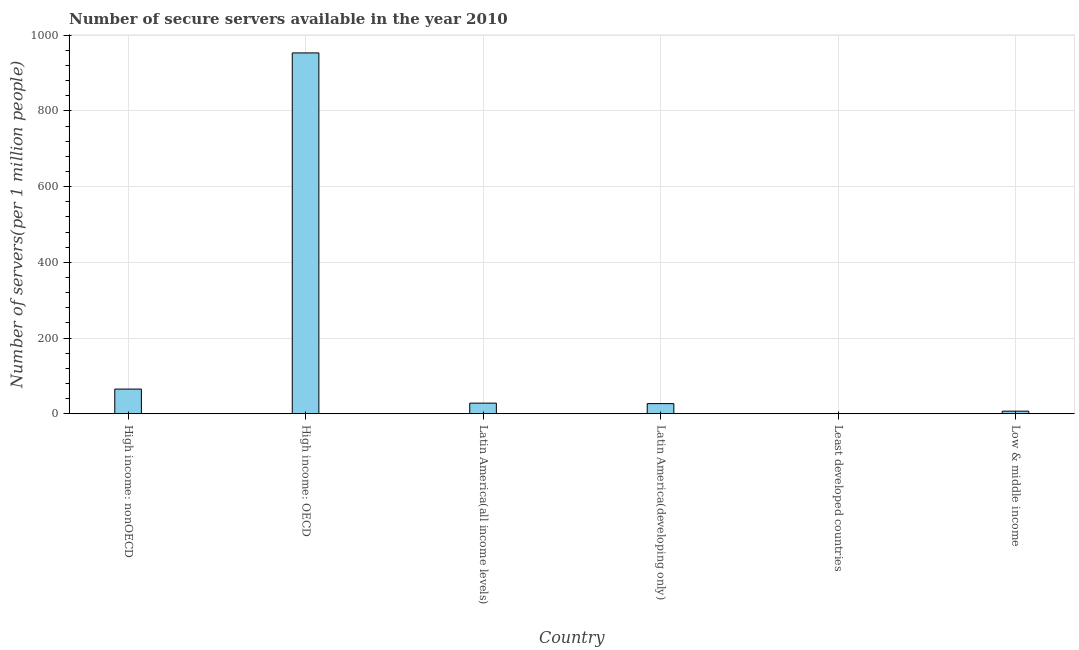Does the graph contain any zero values?
Give a very brief answer. No. What is the title of the graph?
Make the answer very short. Number of secure servers available in the year 2010. What is the label or title of the X-axis?
Ensure brevity in your answer.  Country. What is the label or title of the Y-axis?
Ensure brevity in your answer.  Number of servers(per 1 million people). What is the number of secure internet servers in High income: nonOECD?
Offer a terse response. 65.12. Across all countries, what is the maximum number of secure internet servers?
Provide a short and direct response. 953.1. Across all countries, what is the minimum number of secure internet servers?
Keep it short and to the point. 0.58. In which country was the number of secure internet servers maximum?
Provide a short and direct response. High income: OECD. In which country was the number of secure internet servers minimum?
Your answer should be compact. Least developed countries. What is the sum of the number of secure internet servers?
Offer a very short reply. 1080.34. What is the difference between the number of secure internet servers in Latin America(developing only) and Low & middle income?
Ensure brevity in your answer.  19.97. What is the average number of secure internet servers per country?
Keep it short and to the point. 180.06. What is the median number of secure internet servers?
Your answer should be very brief. 27.37. In how many countries, is the number of secure internet servers greater than 200 ?
Your answer should be very brief. 1. What is the ratio of the number of secure internet servers in High income: nonOECD to that in Low & middle income?
Give a very brief answer. 9.6. Is the number of secure internet servers in High income: nonOECD less than that in Low & middle income?
Ensure brevity in your answer.  No. Is the difference between the number of secure internet servers in Latin America(developing only) and Least developed countries greater than the difference between any two countries?
Keep it short and to the point. No. What is the difference between the highest and the second highest number of secure internet servers?
Make the answer very short. 887.98. Is the sum of the number of secure internet servers in High income: OECD and Latin America(developing only) greater than the maximum number of secure internet servers across all countries?
Your answer should be compact. Yes. What is the difference between the highest and the lowest number of secure internet servers?
Your answer should be very brief. 952.52. In how many countries, is the number of secure internet servers greater than the average number of secure internet servers taken over all countries?
Keep it short and to the point. 1. How many bars are there?
Your answer should be compact. 6. Are all the bars in the graph horizontal?
Your answer should be very brief. No. How many countries are there in the graph?
Your answer should be very brief. 6. What is the difference between two consecutive major ticks on the Y-axis?
Ensure brevity in your answer.  200. What is the Number of servers(per 1 million people) of High income: nonOECD?
Offer a terse response. 65.12. What is the Number of servers(per 1 million people) of High income: OECD?
Ensure brevity in your answer.  953.1. What is the Number of servers(per 1 million people) in Latin America(all income levels)?
Your response must be concise. 27.99. What is the Number of servers(per 1 million people) of Latin America(developing only)?
Provide a short and direct response. 26.75. What is the Number of servers(per 1 million people) in Least developed countries?
Make the answer very short. 0.58. What is the Number of servers(per 1 million people) of Low & middle income?
Make the answer very short. 6.78. What is the difference between the Number of servers(per 1 million people) in High income: nonOECD and High income: OECD?
Your answer should be compact. -887.98. What is the difference between the Number of servers(per 1 million people) in High income: nonOECD and Latin America(all income levels)?
Offer a very short reply. 37.13. What is the difference between the Number of servers(per 1 million people) in High income: nonOECD and Latin America(developing only)?
Keep it short and to the point. 38.37. What is the difference between the Number of servers(per 1 million people) in High income: nonOECD and Least developed countries?
Keep it short and to the point. 64.54. What is the difference between the Number of servers(per 1 million people) in High income: nonOECD and Low & middle income?
Your answer should be compact. 58.34. What is the difference between the Number of servers(per 1 million people) in High income: OECD and Latin America(all income levels)?
Give a very brief answer. 925.11. What is the difference between the Number of servers(per 1 million people) in High income: OECD and Latin America(developing only)?
Provide a succinct answer. 926.35. What is the difference between the Number of servers(per 1 million people) in High income: OECD and Least developed countries?
Your response must be concise. 952.52. What is the difference between the Number of servers(per 1 million people) in High income: OECD and Low & middle income?
Ensure brevity in your answer.  946.32. What is the difference between the Number of servers(per 1 million people) in Latin America(all income levels) and Latin America(developing only)?
Keep it short and to the point. 1.24. What is the difference between the Number of servers(per 1 million people) in Latin America(all income levels) and Least developed countries?
Your response must be concise. 27.41. What is the difference between the Number of servers(per 1 million people) in Latin America(all income levels) and Low & middle income?
Your response must be concise. 21.21. What is the difference between the Number of servers(per 1 million people) in Latin America(developing only) and Least developed countries?
Provide a short and direct response. 26.17. What is the difference between the Number of servers(per 1 million people) in Latin America(developing only) and Low & middle income?
Ensure brevity in your answer.  19.97. What is the ratio of the Number of servers(per 1 million people) in High income: nonOECD to that in High income: OECD?
Offer a very short reply. 0.07. What is the ratio of the Number of servers(per 1 million people) in High income: nonOECD to that in Latin America(all income levels)?
Your answer should be very brief. 2.33. What is the ratio of the Number of servers(per 1 million people) in High income: nonOECD to that in Latin America(developing only)?
Keep it short and to the point. 2.43. What is the ratio of the Number of servers(per 1 million people) in High income: nonOECD to that in Least developed countries?
Your response must be concise. 111.71. What is the ratio of the Number of servers(per 1 million people) in High income: nonOECD to that in Low & middle income?
Give a very brief answer. 9.6. What is the ratio of the Number of servers(per 1 million people) in High income: OECD to that in Latin America(all income levels)?
Give a very brief answer. 34.05. What is the ratio of the Number of servers(per 1 million people) in High income: OECD to that in Latin America(developing only)?
Ensure brevity in your answer.  35.62. What is the ratio of the Number of servers(per 1 million people) in High income: OECD to that in Least developed countries?
Ensure brevity in your answer.  1634.97. What is the ratio of the Number of servers(per 1 million people) in High income: OECD to that in Low & middle income?
Your answer should be compact. 140.51. What is the ratio of the Number of servers(per 1 million people) in Latin America(all income levels) to that in Latin America(developing only)?
Your response must be concise. 1.05. What is the ratio of the Number of servers(per 1 million people) in Latin America(all income levels) to that in Least developed countries?
Give a very brief answer. 48.02. What is the ratio of the Number of servers(per 1 million people) in Latin America(all income levels) to that in Low & middle income?
Offer a terse response. 4.13. What is the ratio of the Number of servers(per 1 million people) in Latin America(developing only) to that in Least developed countries?
Give a very brief answer. 45.9. What is the ratio of the Number of servers(per 1 million people) in Latin America(developing only) to that in Low & middle income?
Your answer should be compact. 3.94. What is the ratio of the Number of servers(per 1 million people) in Least developed countries to that in Low & middle income?
Your response must be concise. 0.09. 